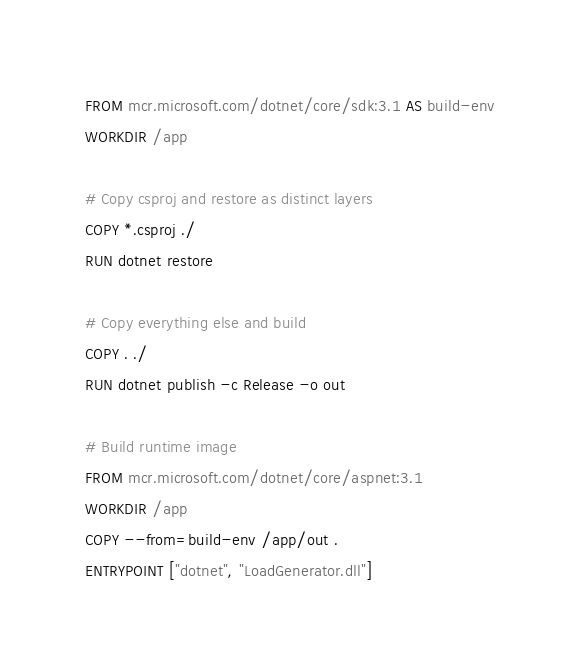Convert code to text. <code><loc_0><loc_0><loc_500><loc_500><_Dockerfile_>FROM mcr.microsoft.com/dotnet/core/sdk:3.1 AS build-env
WORKDIR /app

# Copy csproj and restore as distinct layers
COPY *.csproj ./
RUN dotnet restore

# Copy everything else and build
COPY . ./
RUN dotnet publish -c Release -o out

# Build runtime image
FROM mcr.microsoft.com/dotnet/core/aspnet:3.1
WORKDIR /app
COPY --from=build-env /app/out .
ENTRYPOINT ["dotnet", "LoadGenerator.dll"]</code> 